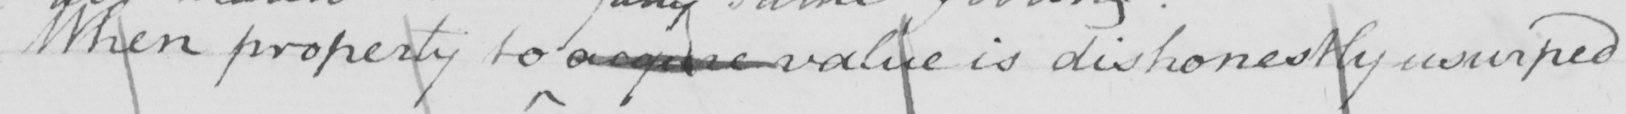Transcribe the text shown in this historical manuscript line. When property to acquire value is dishonestly usurped 